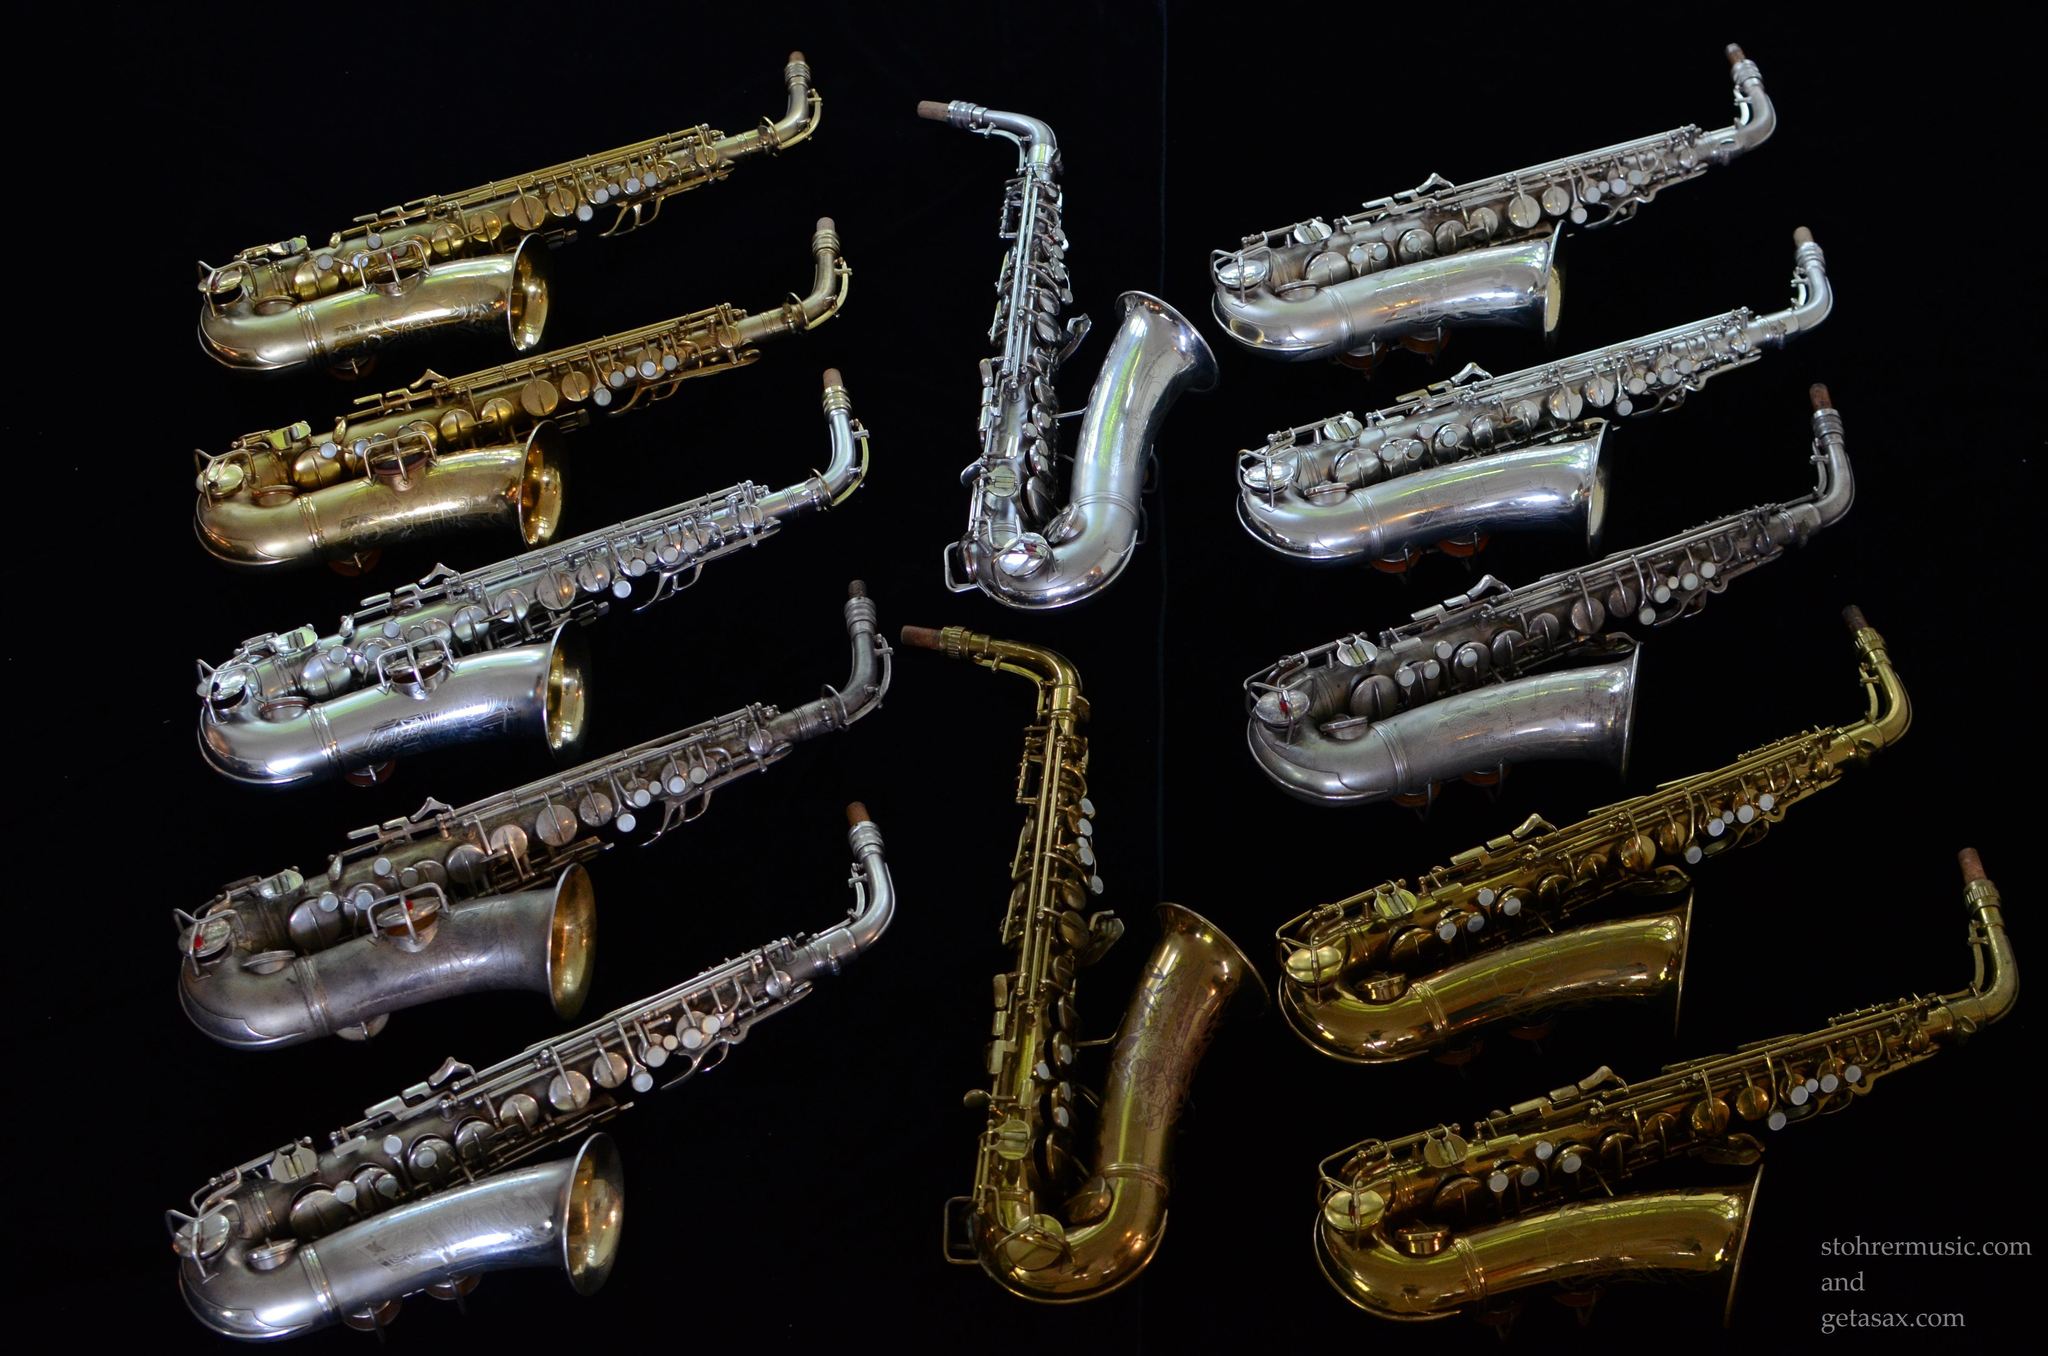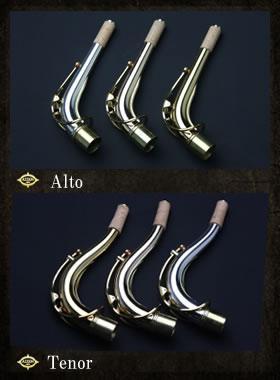The first image is the image on the left, the second image is the image on the right. Assess this claim about the two images: "There are less than five musical instruments.". Correct or not? Answer yes or no. No. The first image is the image on the left, the second image is the image on the right. For the images shown, is this caption "A total of at least three mouthpieces are shown separate from a saxophone." true? Answer yes or no. Yes. 